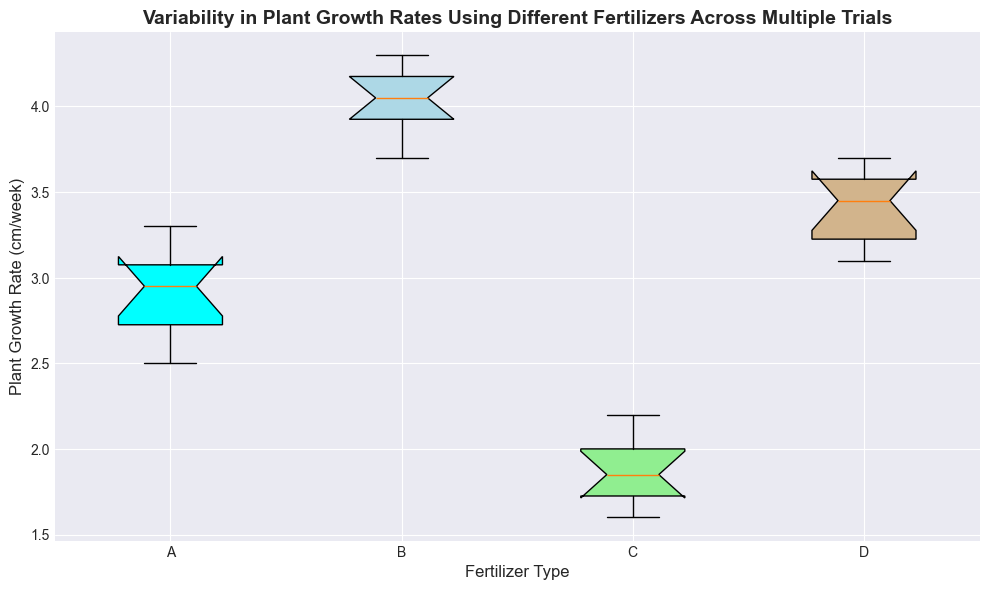What is the median plant growth rate for Fertilizer A? The box plot's median for Fertilizer A is indicated by the line inside the box for the A group. Observing the plot, the median line falls around 2.9 cm/week.
Answer: 2.9 cm/week Which fertilizer type shows the highest median growth rate? To find the highest median growth rate, look for the box with the highest middle line. Fertilizer B's box shows the highest median line, indicating it's the highest among A, B, C, and D.
Answer: Fertilizer B What is the interquartile range (IQR) of plant growth rates for Fertilizer D? The IQR is the range between the first quartile (bottom of the box) and the third quartile (top of the box). For Fertilizer D, the bottom of the box is around 3.2 cm/week, and the top is around 3.5 cm/week, giving an IQR of 3.5 - 3.2.
Answer: 0.3 cm/week Which fertilizer type has the smallest variability in plant growth rates? Variability is represented by the length of the box. The shorter the box, the smaller the variability. Fertilizer C has the shortest box, indicating the smallest variability.
Answer: Fertilizer C What is the range of plant growth rates for Fertilizer B? The range is the difference between the maximum and minimum values indicated by the whiskers. For Fertilizer B, it ranges from about 3.7 to about 4.3 cm/week.
Answer: 0.6 cm/week Which fertilizer has outliers in its growth rates? Outliers are shown as points outside the whiskers. Observing the plot, no fertilizer type exhibits outliers as no points are outside the whiskers for any of the fertilizers.
Answer: None How does the variability of plant growth rates for Fertilizer A compare to Fertilizer C? The length of the box indicates variability. Fertilizer A's box is taller than Fertilizer C's, which means Fertilizer A has greater variability compared to Fertilizer C.
Answer: Fertilizer A has more variability Between Fertilizer A and Fertilizer D, which has a higher third quartile value? The third quartile value is represented by the top edge of the box. Fertilizer D's top edge is higher (around 3.5 cm/week) compared to Fertilizer A's top edge (around 3.2 cm/week).
Answer: Fertilizer D What can you conclude about the average growth rate trend observed in Fertilizer types A, B, and C? By observing the medians, the average trend can be inferred. Fertilizer B has the highest median, followed by Fertilizer A, and then Fertilizer C, indicating a decreasing average trend from B to A to C.
Answer: B > A > C 